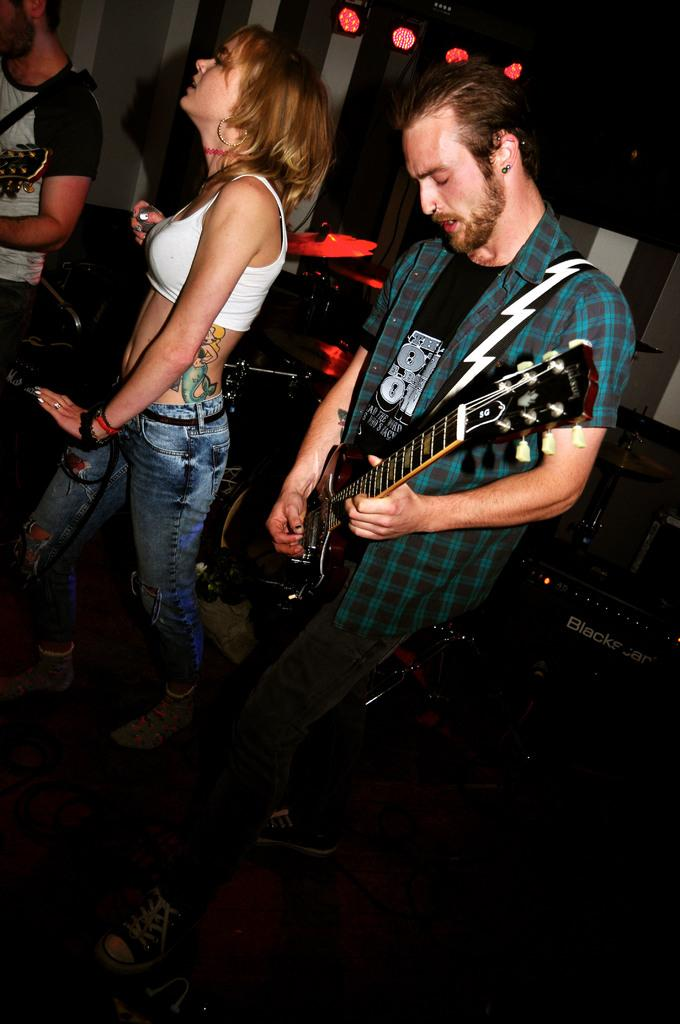How many people are in the image? There are three persons standing on a floor in the image. What is one person doing in the image? One person is playing a guitar. What can be seen behind the three persons? There are musical instruments behind the three persons. What is visible at the top of the picture? There are focusing lights at the top of the picture. What type of animals can be seen at the zoo in the image? There is no zoo or animals present in the image; it features three persons and musical instruments. 